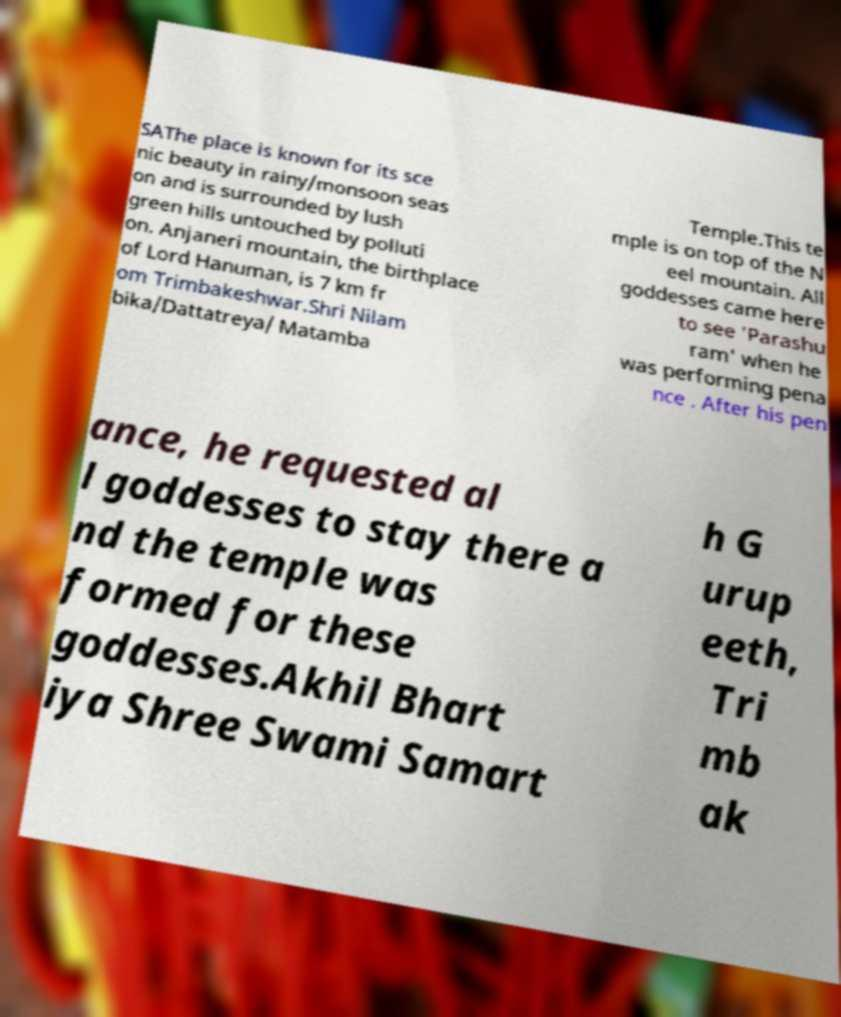There's text embedded in this image that I need extracted. Can you transcribe it verbatim? SAThe place is known for its sce nic beauty in rainy/monsoon seas on and is surrounded by lush green hills untouched by polluti on. Anjaneri mountain, the birthplace of Lord Hanuman, is 7 km fr om Trimbakeshwar.Shri Nilam bika/Dattatreya/ Matamba Temple.This te mple is on top of the N eel mountain. All goddesses came here to see 'Parashu ram' when he was performing pena nce . After his pen ance, he requested al l goddesses to stay there a nd the temple was formed for these goddesses.Akhil Bhart iya Shree Swami Samart h G urup eeth, Tri mb ak 